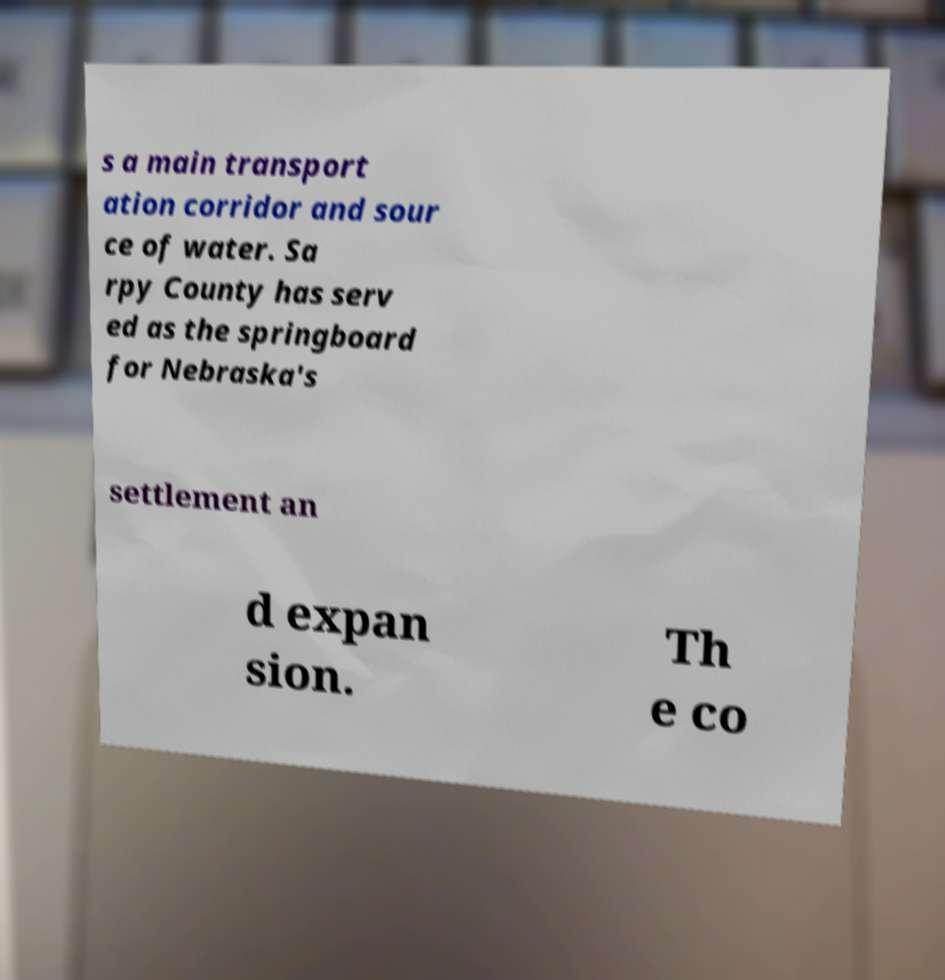Could you extract and type out the text from this image? s a main transport ation corridor and sour ce of water. Sa rpy County has serv ed as the springboard for Nebraska's settlement an d expan sion. Th e co 